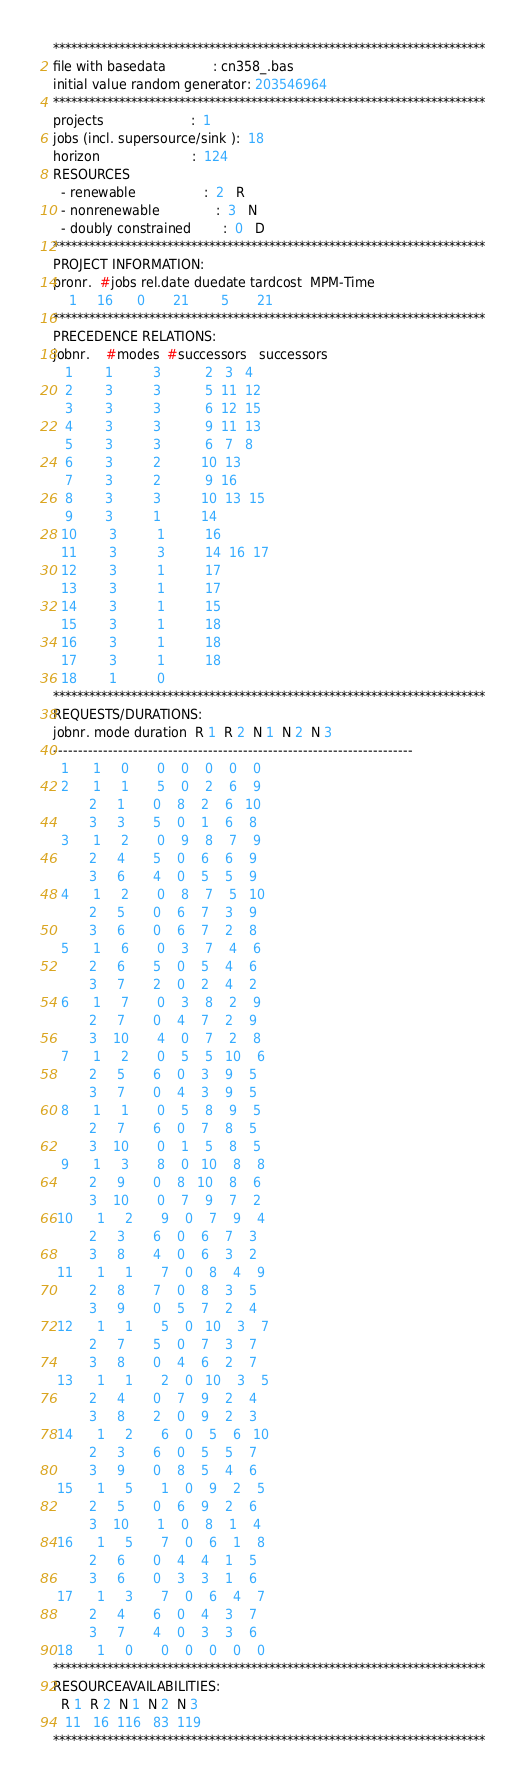<code> <loc_0><loc_0><loc_500><loc_500><_ObjectiveC_>************************************************************************
file with basedata            : cn358_.bas
initial value random generator: 203546964
************************************************************************
projects                      :  1
jobs (incl. supersource/sink ):  18
horizon                       :  124
RESOURCES
  - renewable                 :  2   R
  - nonrenewable              :  3   N
  - doubly constrained        :  0   D
************************************************************************
PROJECT INFORMATION:
pronr.  #jobs rel.date duedate tardcost  MPM-Time
    1     16      0       21        5       21
************************************************************************
PRECEDENCE RELATIONS:
jobnr.    #modes  #successors   successors
   1        1          3           2   3   4
   2        3          3           5  11  12
   3        3          3           6  12  15
   4        3          3           9  11  13
   5        3          3           6   7   8
   6        3          2          10  13
   7        3          2           9  16
   8        3          3          10  13  15
   9        3          1          14
  10        3          1          16
  11        3          3          14  16  17
  12        3          1          17
  13        3          1          17
  14        3          1          15
  15        3          1          18
  16        3          1          18
  17        3          1          18
  18        1          0        
************************************************************************
REQUESTS/DURATIONS:
jobnr. mode duration  R 1  R 2  N 1  N 2  N 3
------------------------------------------------------------------------
  1      1     0       0    0    0    0    0
  2      1     1       5    0    2    6    9
         2     1       0    8    2    6   10
         3     3       5    0    1    6    8
  3      1     2       0    9    8    7    9
         2     4       5    0    6    6    9
         3     6       4    0    5    5    9
  4      1     2       0    8    7    5   10
         2     5       0    6    7    3    9
         3     6       0    6    7    2    8
  5      1     6       0    3    7    4    6
         2     6       5    0    5    4    6
         3     7       2    0    2    4    2
  6      1     7       0    3    8    2    9
         2     7       0    4    7    2    9
         3    10       4    0    7    2    8
  7      1     2       0    5    5   10    6
         2     5       6    0    3    9    5
         3     7       0    4    3    9    5
  8      1     1       0    5    8    9    5
         2     7       6    0    7    8    5
         3    10       0    1    5    8    5
  9      1     3       8    0   10    8    8
         2     9       0    8   10    8    6
         3    10       0    7    9    7    2
 10      1     2       9    0    7    9    4
         2     3       6    0    6    7    3
         3     8       4    0    6    3    2
 11      1     1       7    0    8    4    9
         2     8       7    0    8    3    5
         3     9       0    5    7    2    4
 12      1     1       5    0   10    3    7
         2     7       5    0    7    3    7
         3     8       0    4    6    2    7
 13      1     1       2    0   10    3    5
         2     4       0    7    9    2    4
         3     8       2    0    9    2    3
 14      1     2       6    0    5    6   10
         2     3       6    0    5    5    7
         3     9       0    8    5    4    6
 15      1     5       1    0    9    2    5
         2     5       0    6    9    2    6
         3    10       1    0    8    1    4
 16      1     5       7    0    6    1    8
         2     6       0    4    4    1    5
         3     6       0    3    3    1    6
 17      1     3       7    0    6    4    7
         2     4       6    0    4    3    7
         3     7       4    0    3    3    6
 18      1     0       0    0    0    0    0
************************************************************************
RESOURCEAVAILABILITIES:
  R 1  R 2  N 1  N 2  N 3
   11   16  116   83  119
************************************************************************
</code> 